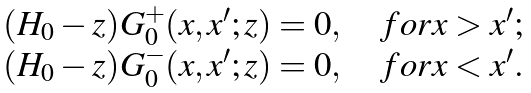<formula> <loc_0><loc_0><loc_500><loc_500>\begin{array} { l } ( H _ { 0 } - z ) G _ { 0 } ^ { + } ( x , x ^ { \prime } ; z ) = 0 , \quad f o r x > x ^ { \prime } ; \\ ( H _ { 0 } - z ) G _ { 0 } ^ { - } ( x , x ^ { \prime } ; z ) = 0 , \quad f o r x < x ^ { \prime } . \end{array}</formula> 